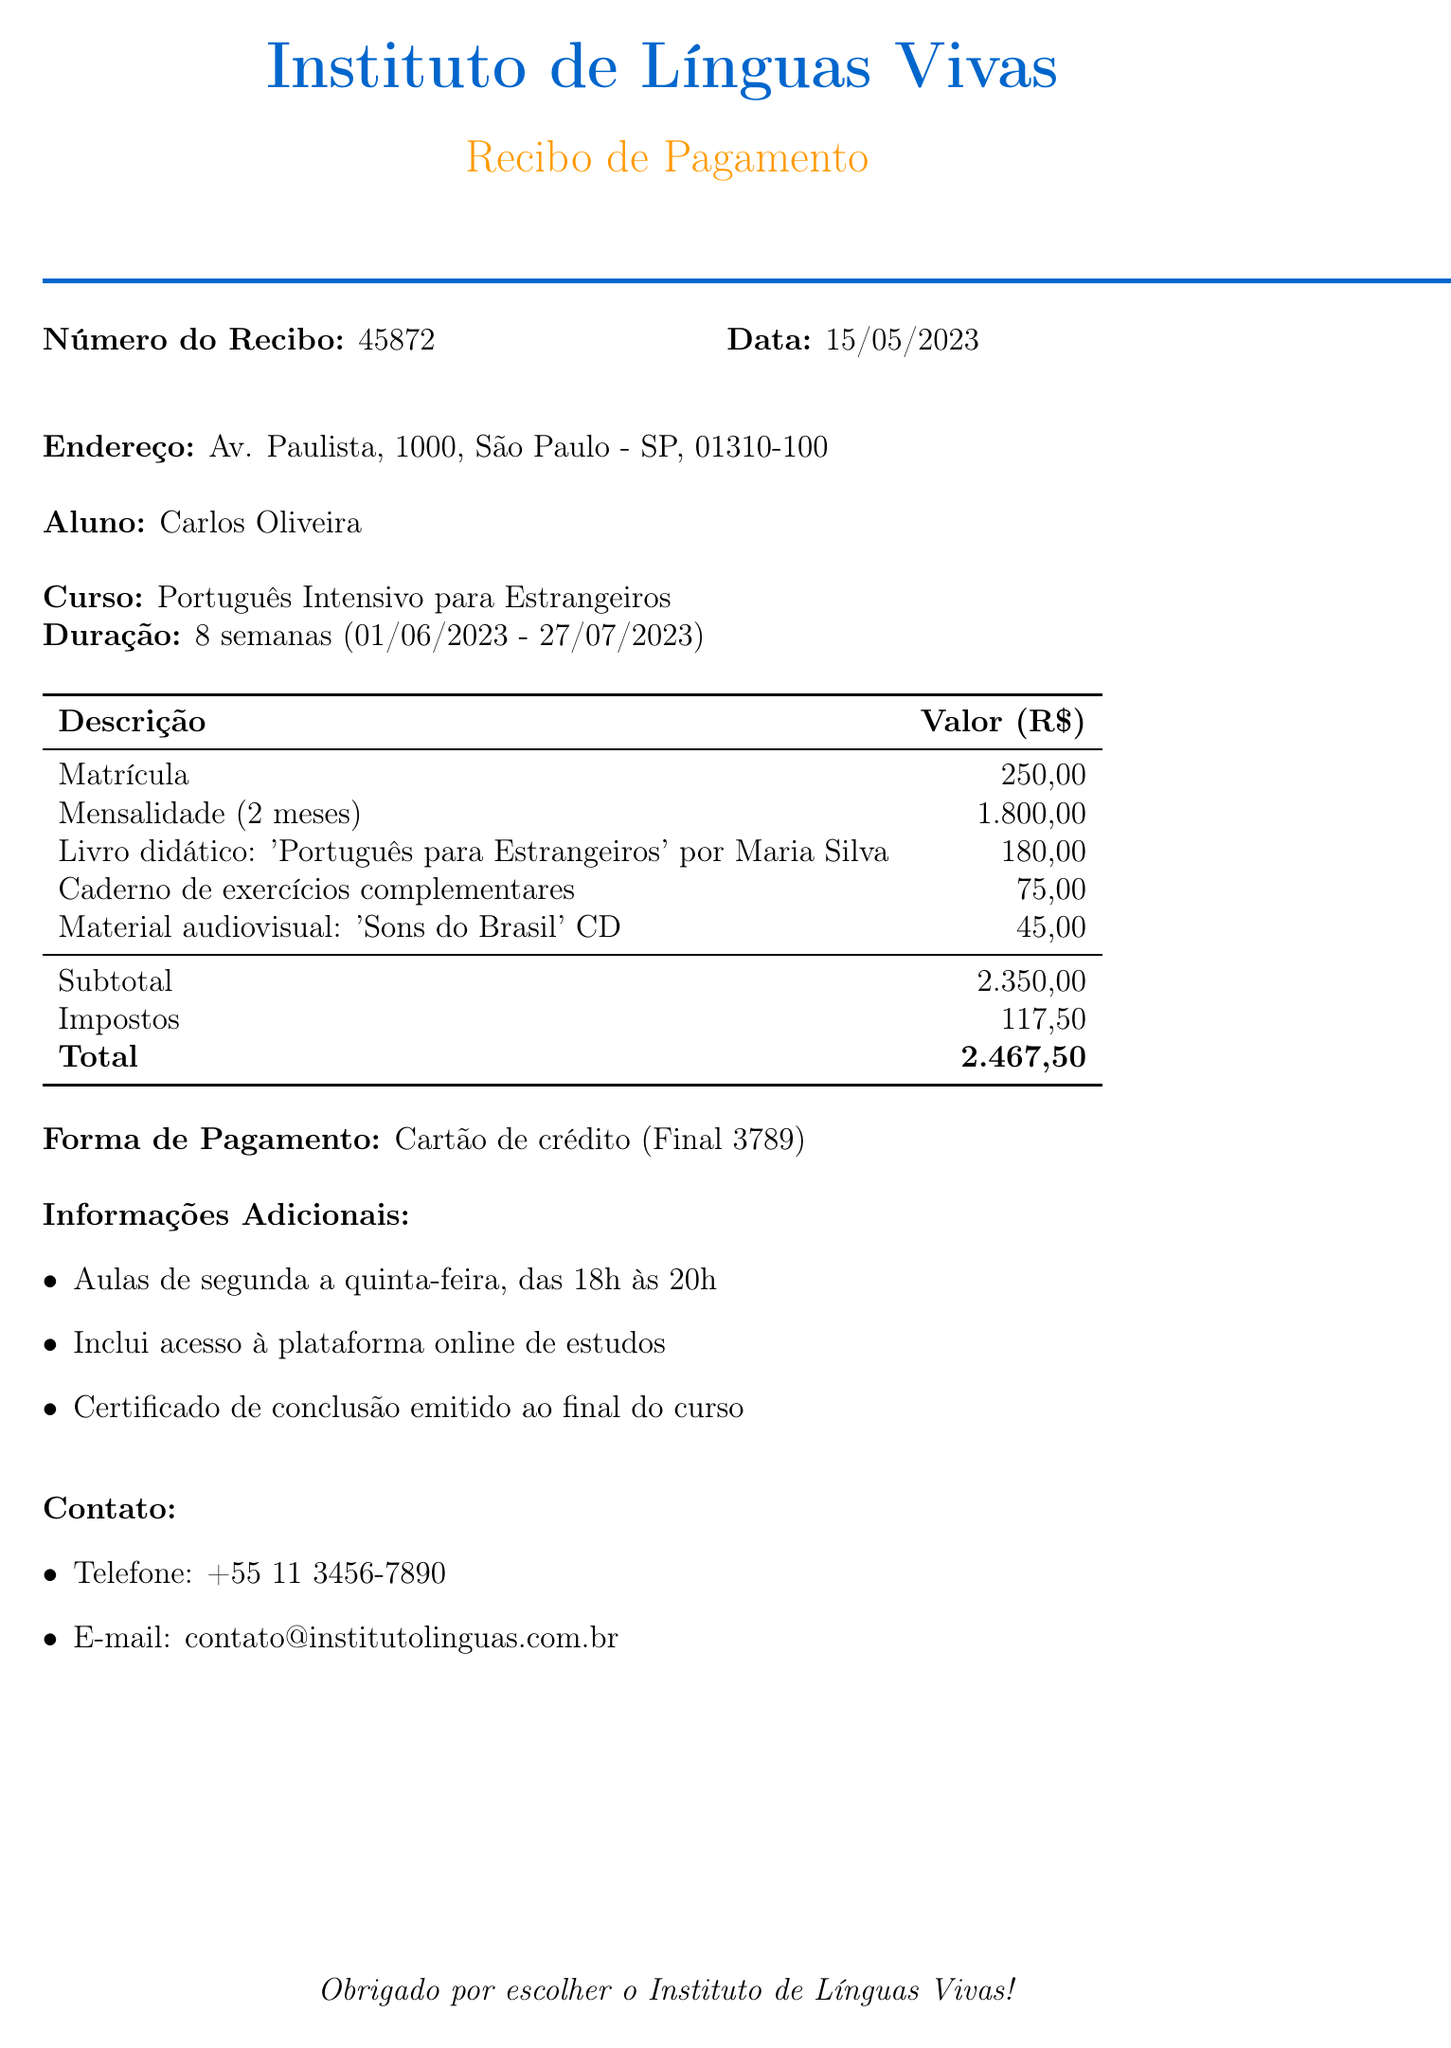what is the student name? The student's name is explicitly listed in the document as Carlos Oliveira.
Answer: Carlos Oliveira what is the course duration? The document states the course duration as 8 semanas (8 weeks).
Answer: 8 semanas what is the total amount paid? The total amount is calculated as the sum of the subtotal and tax, which is R$ 2.350,00 + R$ 117,50.
Answer: 2.467,50 what is the course name? The course name is found in the document as "Português Intensivo para Estrangeiros".
Answer: Português Intensivo para Estrangeiros what is the cost of the registration? The document specifies the cost of registration (Matrícula) as R$ 250,00.
Answer: 250,00 how many months are included in the tuition? The tuition includes a total of 2 months as stated in the item for monthly fees.
Answer: 2 meses what is the payment method used? The document lists the payment method as "Cartão de crédito".
Answer: Cartão de crédito what additional items were purchased? The document lists additional items purchased, including a textbook and exercise notebook, among others.
Answer: Livro didático, Caderno de exercícios complementares, Material audiovisual when does the course start? The course start date is specified in the document as 2023-06-01.
Answer: 2023-06-01 how can one contact the school? The contact information includes phone and email, providing ways to reach out to the school.
Answer: +55 11 3456-7890, contato@institutolinguas.com.br 